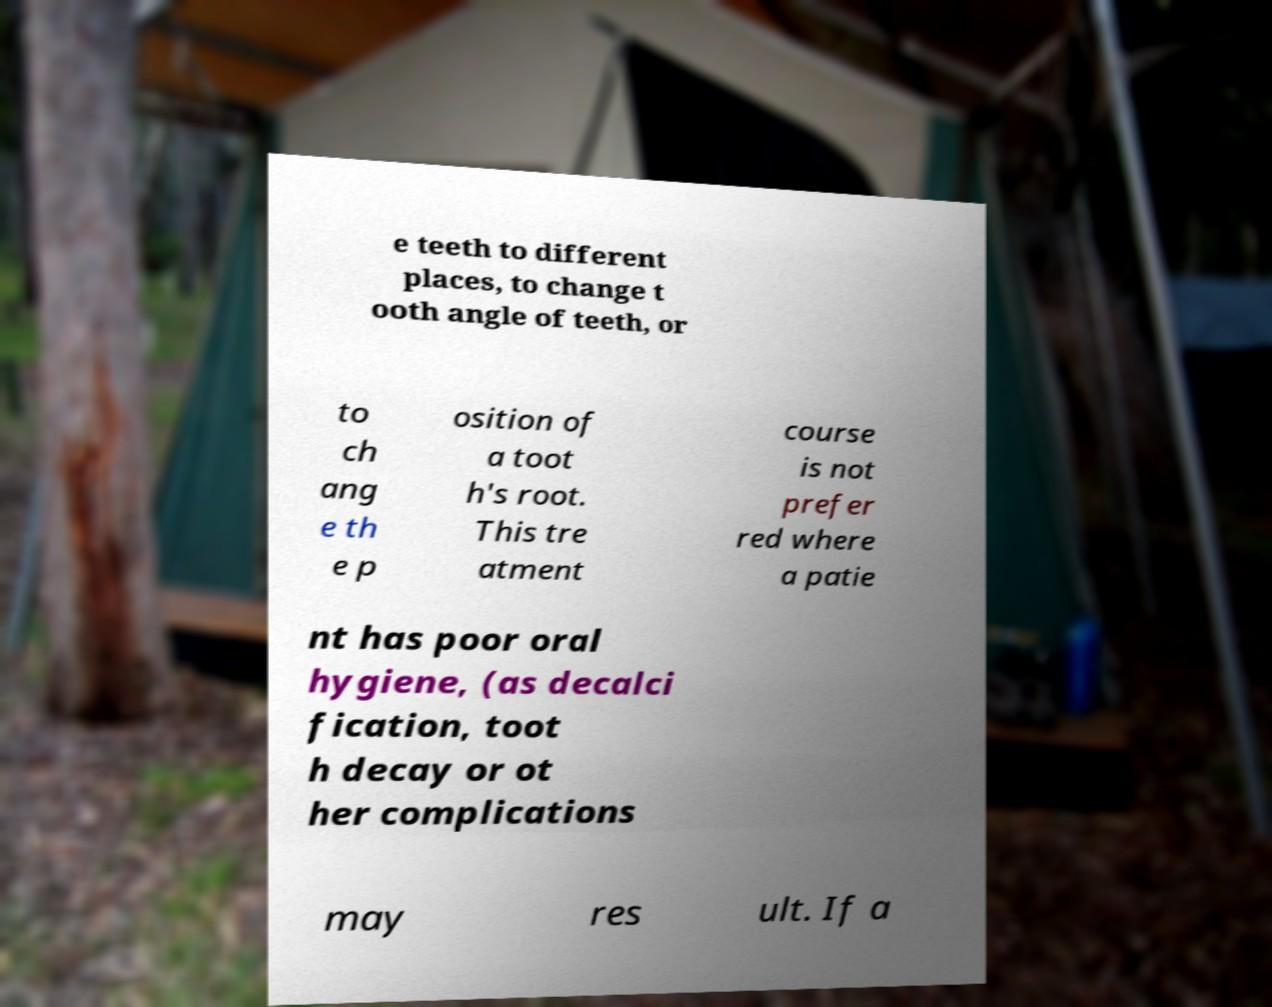Can you accurately transcribe the text from the provided image for me? e teeth to different places, to change t ooth angle of teeth, or to ch ang e th e p osition of a toot h's root. This tre atment course is not prefer red where a patie nt has poor oral hygiene, (as decalci fication, toot h decay or ot her complications may res ult. If a 